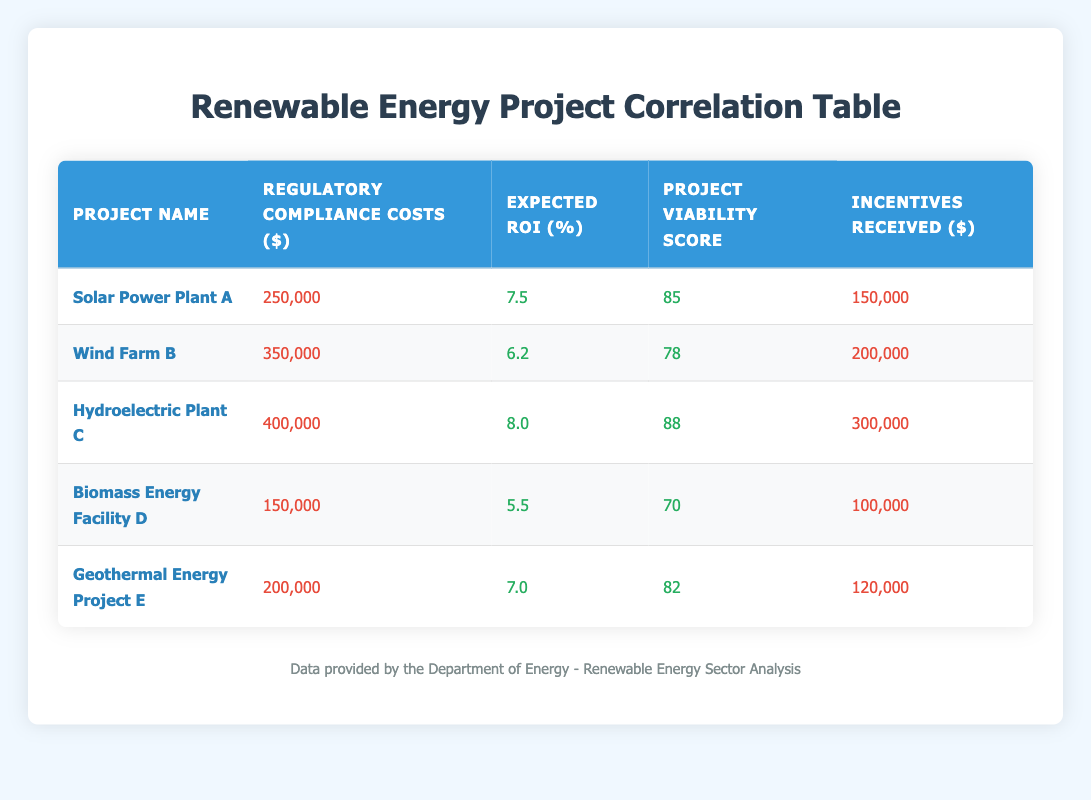What are the regulatory compliance costs for Wind Farm B? The table shows that for Wind Farm B, the regulatory compliance costs are listed as 350,000 dollars.
Answer: 350000 Which project has the highest project viability score? In the table, Hydroelectric Plant C has the highest project viability score at 88.
Answer: Hydroelectric Plant C What is the average expected return on investment for all projects? To find the average, we sum the expected returns: (7.5 + 6.2 + 8.0 + 5.5 + 7.0) = 34.2. There are 5 projects, so the average is 34.2 / 5 = 6.84.
Answer: 6.84 Is the project viability score for Biomass Energy Facility D greater than 75? The table indicates that the project viability score for Biomass Energy Facility D is 70, which is not greater than 75.
Answer: No What is the difference in regulatory compliance costs between Hydroelectric Plant C and Solar Power Plant A? The regulatory compliance costs for Hydroelectric Plant C are 400,000 dollars and for Solar Power Plant A are 250,000 dollars. To find the difference: 400,000 - 250,000 = 150,000 dollars.
Answer: 150000 How many projects received incentives greater than 150,000 dollars? From the table, Wind Farm B (200,000), Hydroelectric Plant C (300,000), and Geothermal Energy Project E (120,000) are checked. Only Wind Farm B and Hydroelectric Plant C have incentives greater than 150,000 dollars. Therefore, there are 2 projects.
Answer: 2 Are the expected returns on investment for all projects above 5 percent? Looking at the expected returns, only Biomass Energy Facility D has 5.5 percent, while the others are above 5 percent: Solar Power Plant A (7.5), Wind Farm B (6.2), Hydroelectric Plant C (8.0), and Geothermal Energy Project E (7.0). Hence, yes, all projects meet this condition.
Answer: Yes What is the total amount of regulatory compliance costs for all projects? The total is calculated by summing all compliance costs: 250,000 + 350,000 + 400,000 + 150,000 + 200,000 = 1,350,000 dollars.
Answer: 1350000 Which project has the lowest expected return on investment and what is that return? The table shows that Biomass Energy Facility D has the lowest expected return on investment at 5.5 percent.
Answer: Biomass Energy Facility D, 5.5 percent 